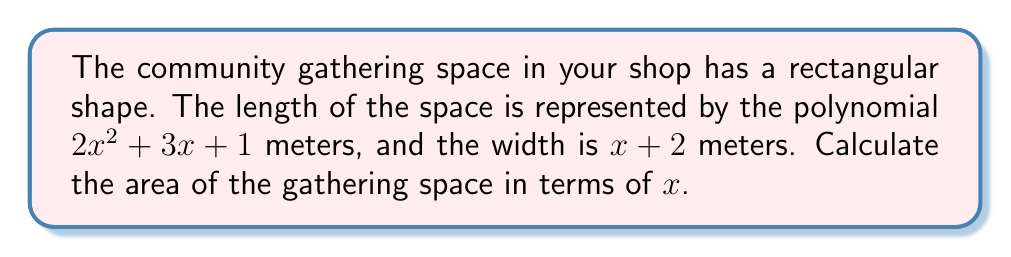Could you help me with this problem? To calculate the area of a rectangular space, we multiply the length by the width. In this case, we need to multiply two polynomials:

1) Length: $2x^2 + 3x + 1$
2) Width: $x + 2$

Let's multiply these polynomials using the FOIL method and combining like terms:

$$(2x^2 + 3x + 1)(x + 2)$$

1) First terms: $2x^2 \cdot x = 2x^3$
2) Outer terms: $2x^2 \cdot 2 = 4x^2$
3) Inner terms: $3x \cdot x = 3x^2$
4) Last terms: $3x \cdot 2 = 6x$
5) First terms (again): $1 \cdot x = x$
6) Last terms (again): $1 \cdot 2 = 2$

Now, let's combine like terms:

$$2x^3 + 4x^2 + 3x^2 + 6x + x + 2$$
$$= 2x^3 + 7x^2 + 7x + 2$$

This polynomial represents the area of the community gathering space in square meters.
Answer: $2x^3 + 7x^2 + 7x + 2$ square meters 